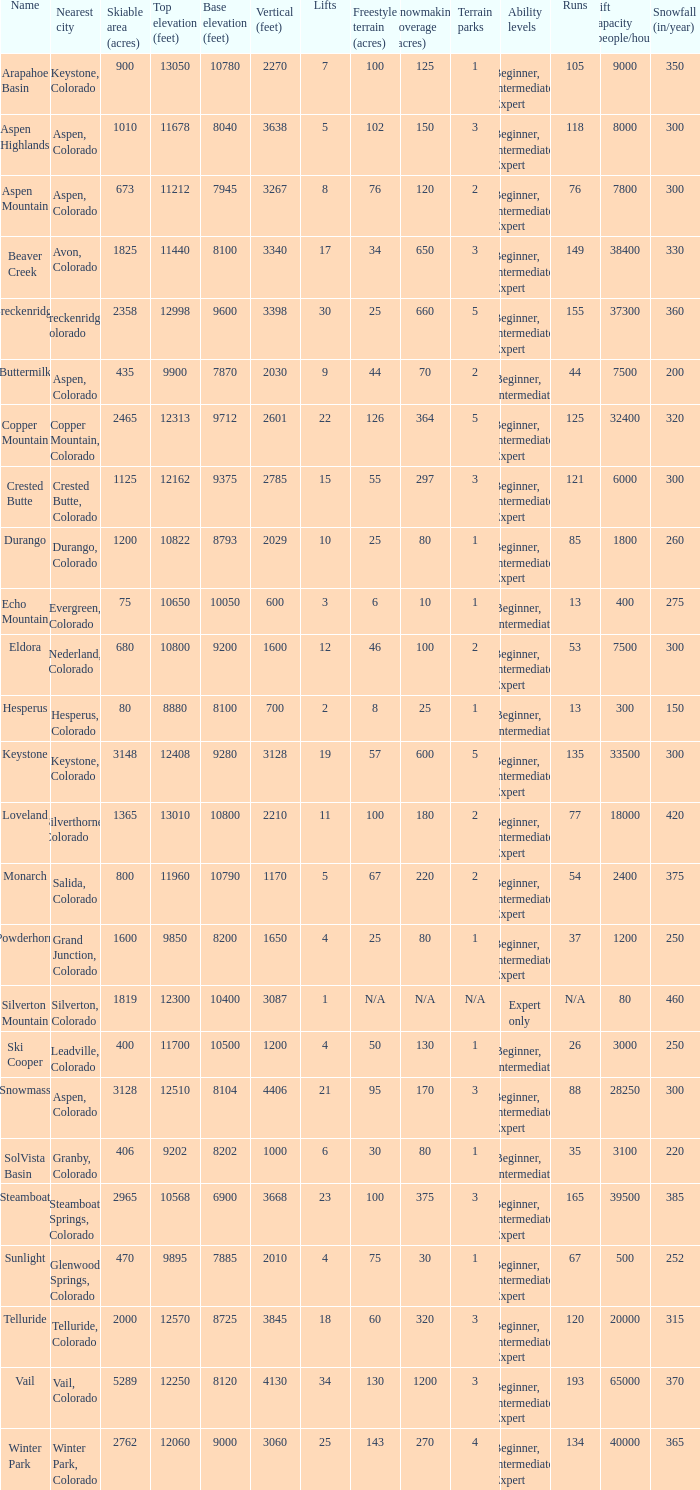If there are 30 lifts, what is the name of the ski resort? Breckenridge. 